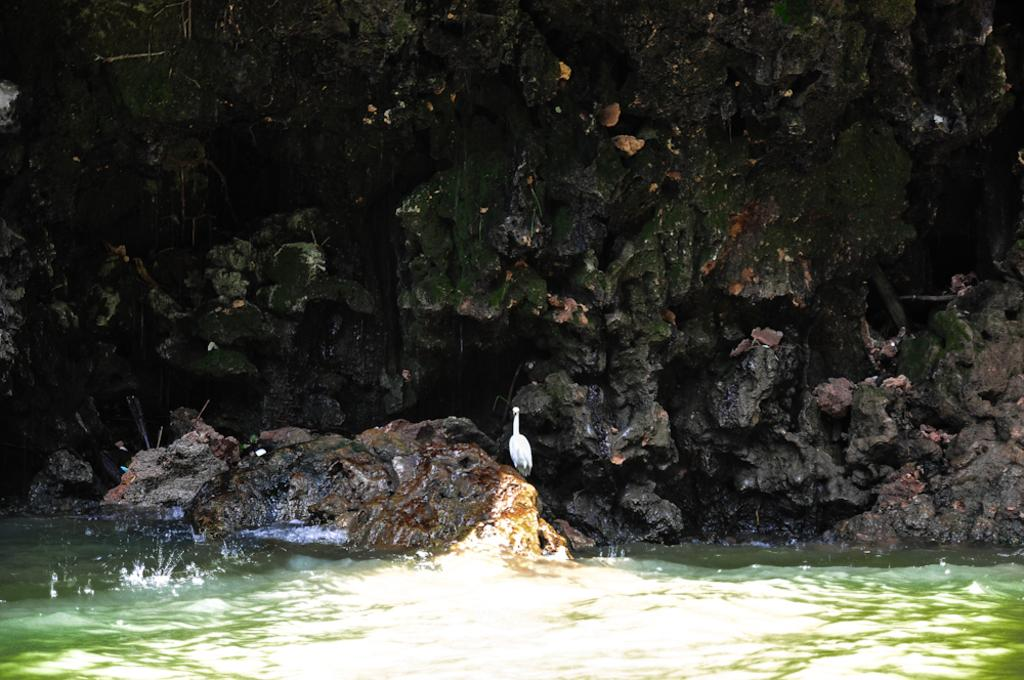What is the main subject in the image? There is a crane in the image. Where is the crane located? The crane is on a stone. What can be seen in the background of the image? There is a rock wall in the background of the image. What is visible at the bottom of the image? There is water visible at the bottom of the image. How does the crane feel about its mother in the image? There is no indication of the crane's feelings or the presence of a mother in the image. 